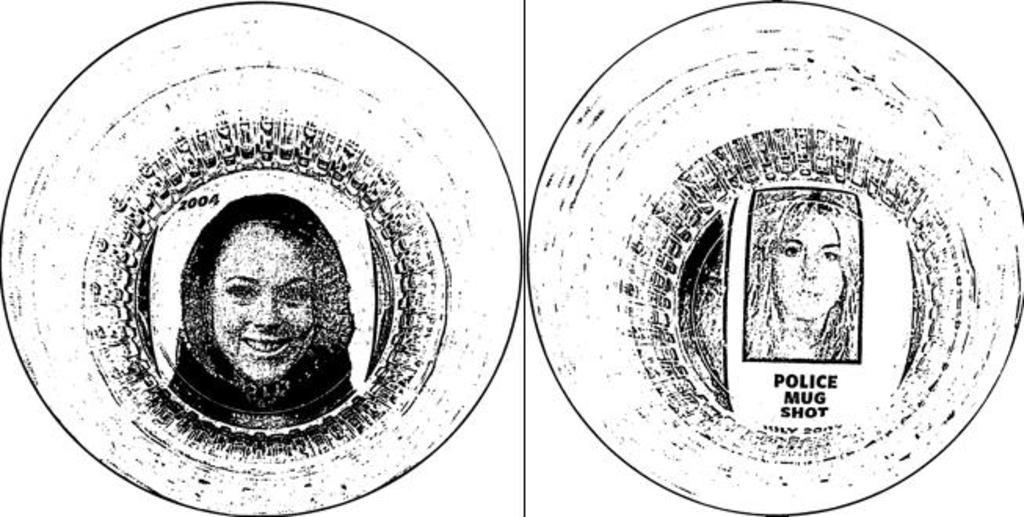What type of composition is the image? The image is a collage of two pictures. What can be found in the first picture of the collage? The first picture contains numbers. What is featured in the second picture of the collage? The second picture contains text. What type of feather is used to write the text in the second picture? There is no feather present in the image, and the text is not written by hand. 